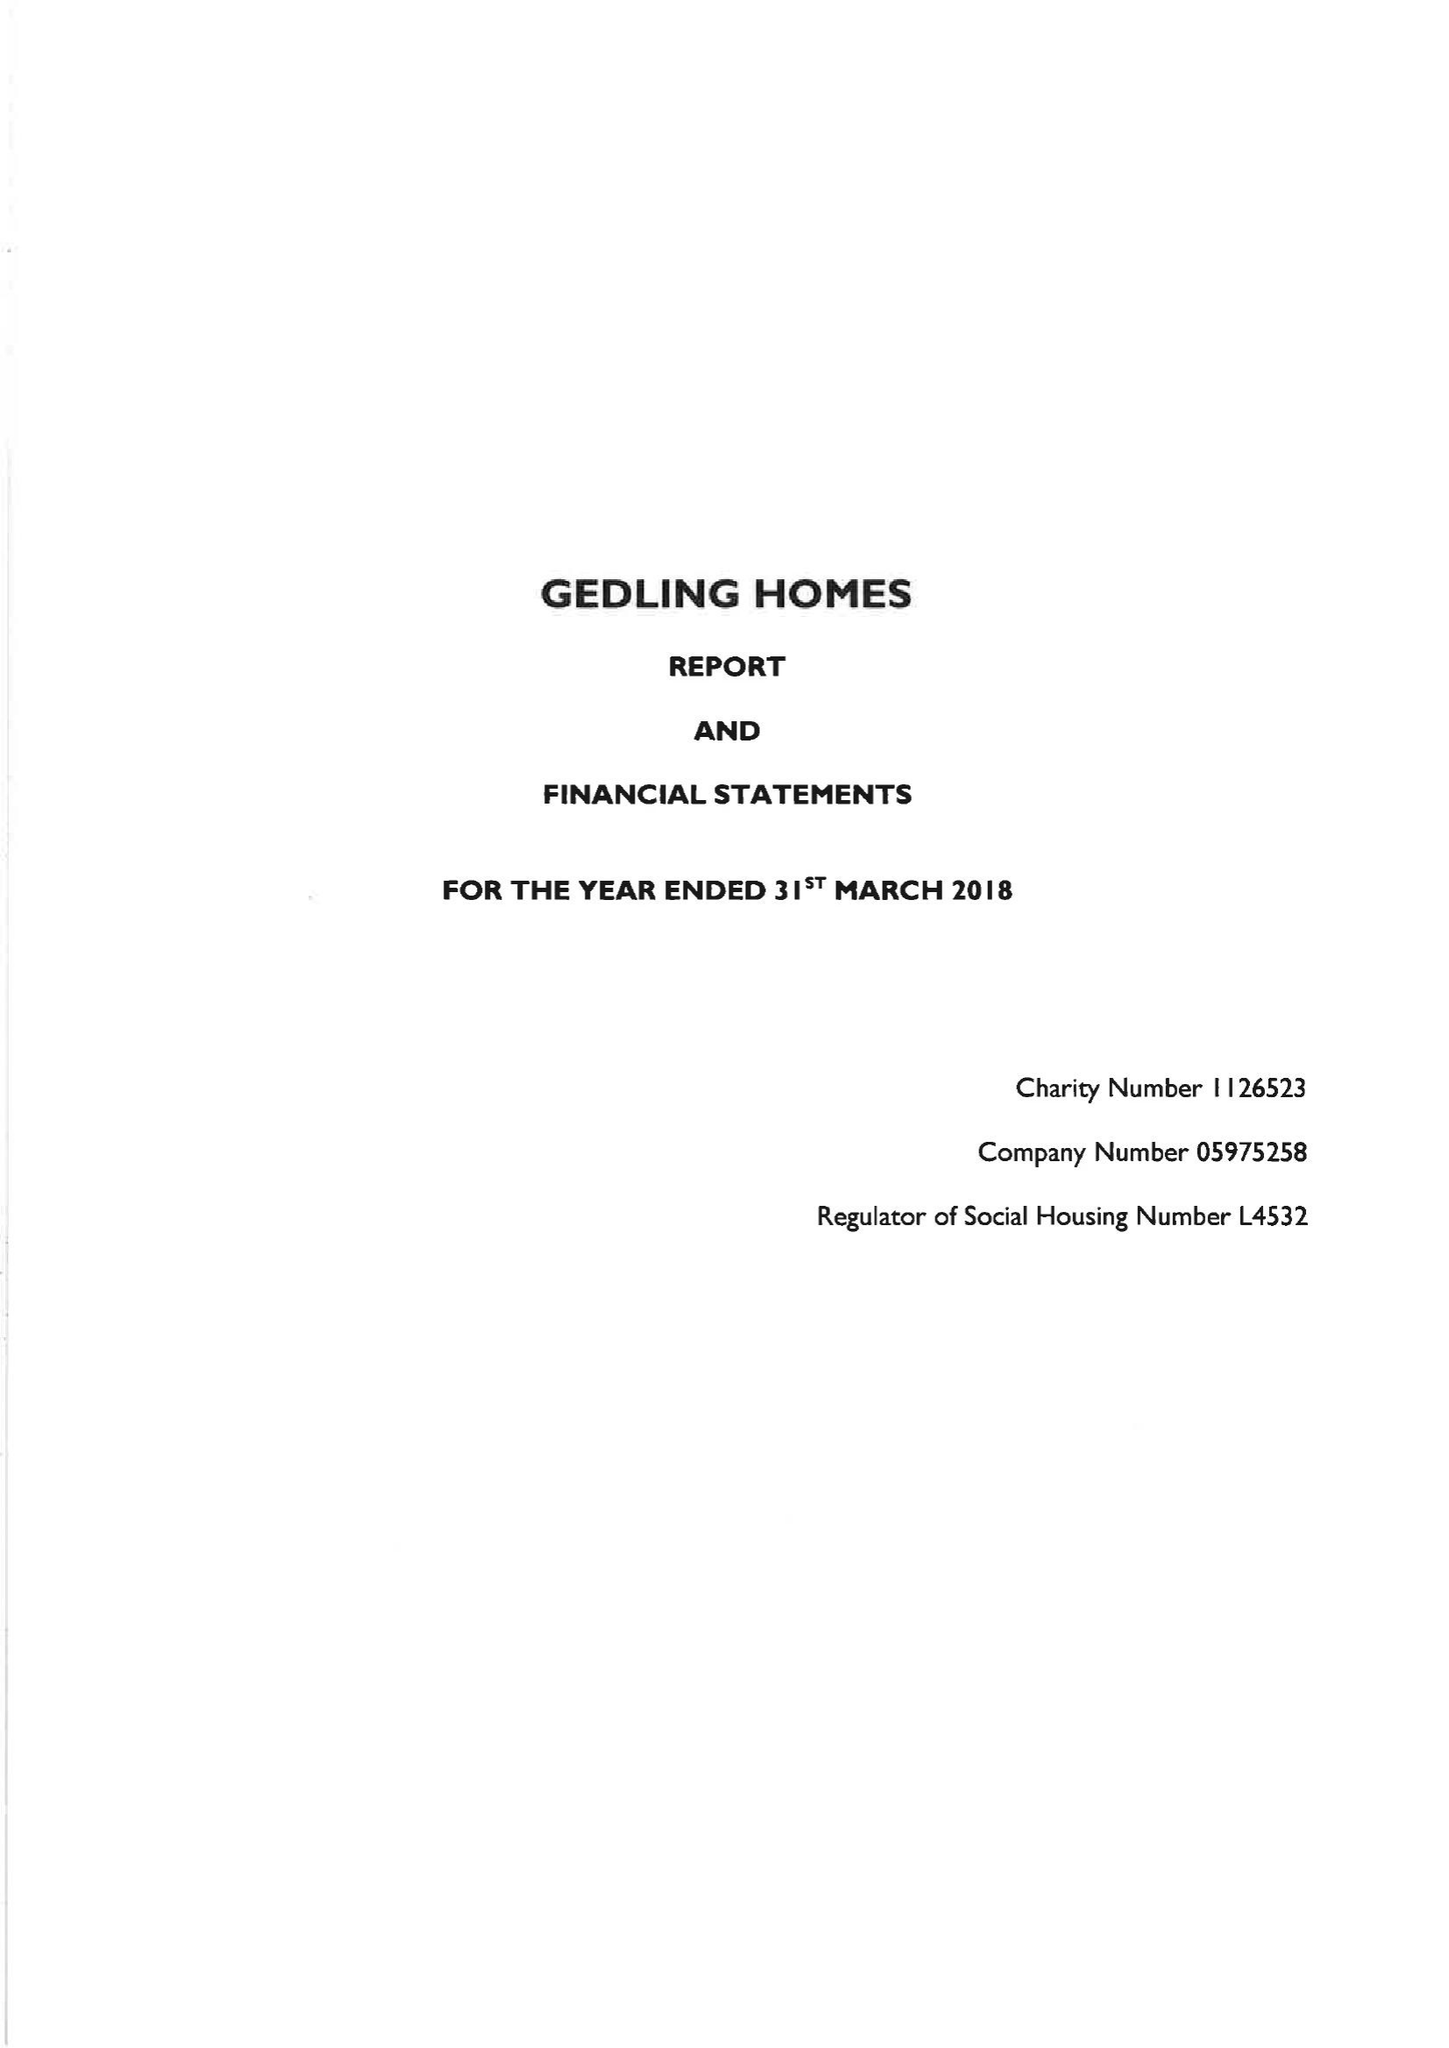What is the value for the address__post_town?
Answer the question using a single word or phrase. ASHTON-UNDER-LYNE 